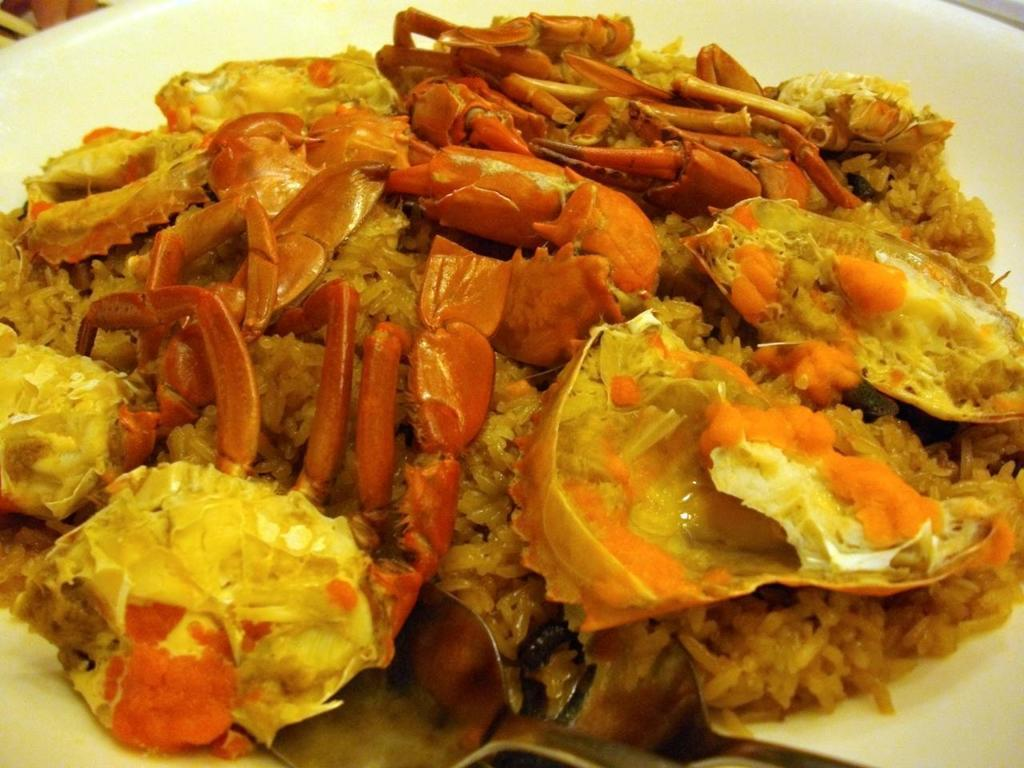What is on the plate that is visible in the image? There is a white plate in the image. What is on top of the white plate? There is food on the plate. Can you describe the colors of the food on the plate? The food has a brown color and a yellow color. What type of cap is being worn by the food on the plate? There are no caps present in the image, as the subject is food on a plate. 